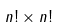Convert formula to latex. <formula><loc_0><loc_0><loc_500><loc_500>n ! \times n !</formula> 